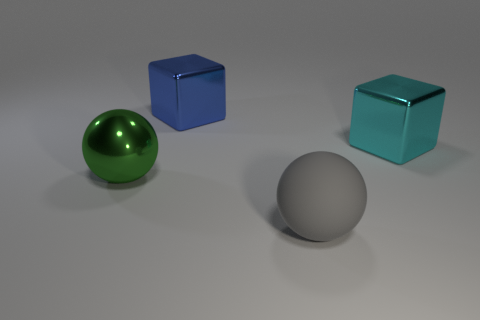Add 3 matte things. How many objects exist? 7 Subtract 2 balls. How many balls are left? 0 Subtract all blue cubes. How many cubes are left? 1 Subtract all green metal things. Subtract all metallic blocks. How many objects are left? 1 Add 3 blue metallic cubes. How many blue metallic cubes are left? 4 Add 4 large rubber balls. How many large rubber balls exist? 5 Subtract 0 cyan spheres. How many objects are left? 4 Subtract all blue spheres. Subtract all red blocks. How many spheres are left? 2 